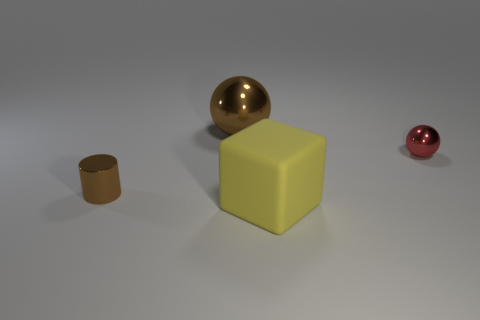Add 1 small metallic cylinders. How many objects exist? 5 Subtract all small green shiny cylinders. Subtract all brown things. How many objects are left? 2 Add 4 big brown objects. How many big brown objects are left? 5 Add 2 tiny metallic cylinders. How many tiny metallic cylinders exist? 3 Subtract 0 purple cubes. How many objects are left? 4 Subtract all blocks. How many objects are left? 3 Subtract all blue balls. Subtract all cyan cylinders. How many balls are left? 2 